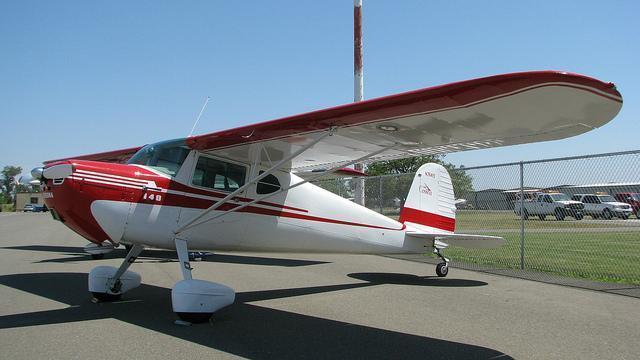How many wheels are used on the bottom of this aircraft?
Make your selection from the four choices given to correctly answer the question.
Options: Eight, twelve, three, six. Three. 